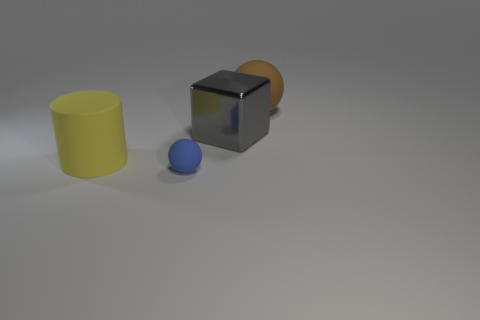Are there any other things that are the same size as the blue matte ball?
Your response must be concise. No. There is a big thing that is behind the matte cylinder and in front of the large brown matte thing; what color is it?
Offer a very short reply. Gray. What material is the blue thing?
Your answer should be very brief. Rubber. There is a big matte thing that is on the right side of the cylinder; what is its shape?
Offer a terse response. Sphere. What is the color of the cylinder that is the same size as the cube?
Give a very brief answer. Yellow. Is the big object in front of the big gray object made of the same material as the small blue object?
Provide a short and direct response. Yes. How big is the thing that is both on the left side of the large brown sphere and to the right of the blue thing?
Offer a terse response. Large. How big is the matte object left of the tiny blue object?
Offer a very short reply. Large. What is the shape of the large matte thing that is in front of the matte object that is right of the tiny object in front of the large yellow object?
Offer a terse response. Cylinder. How many other objects are the same shape as the large yellow matte object?
Offer a terse response. 0. 